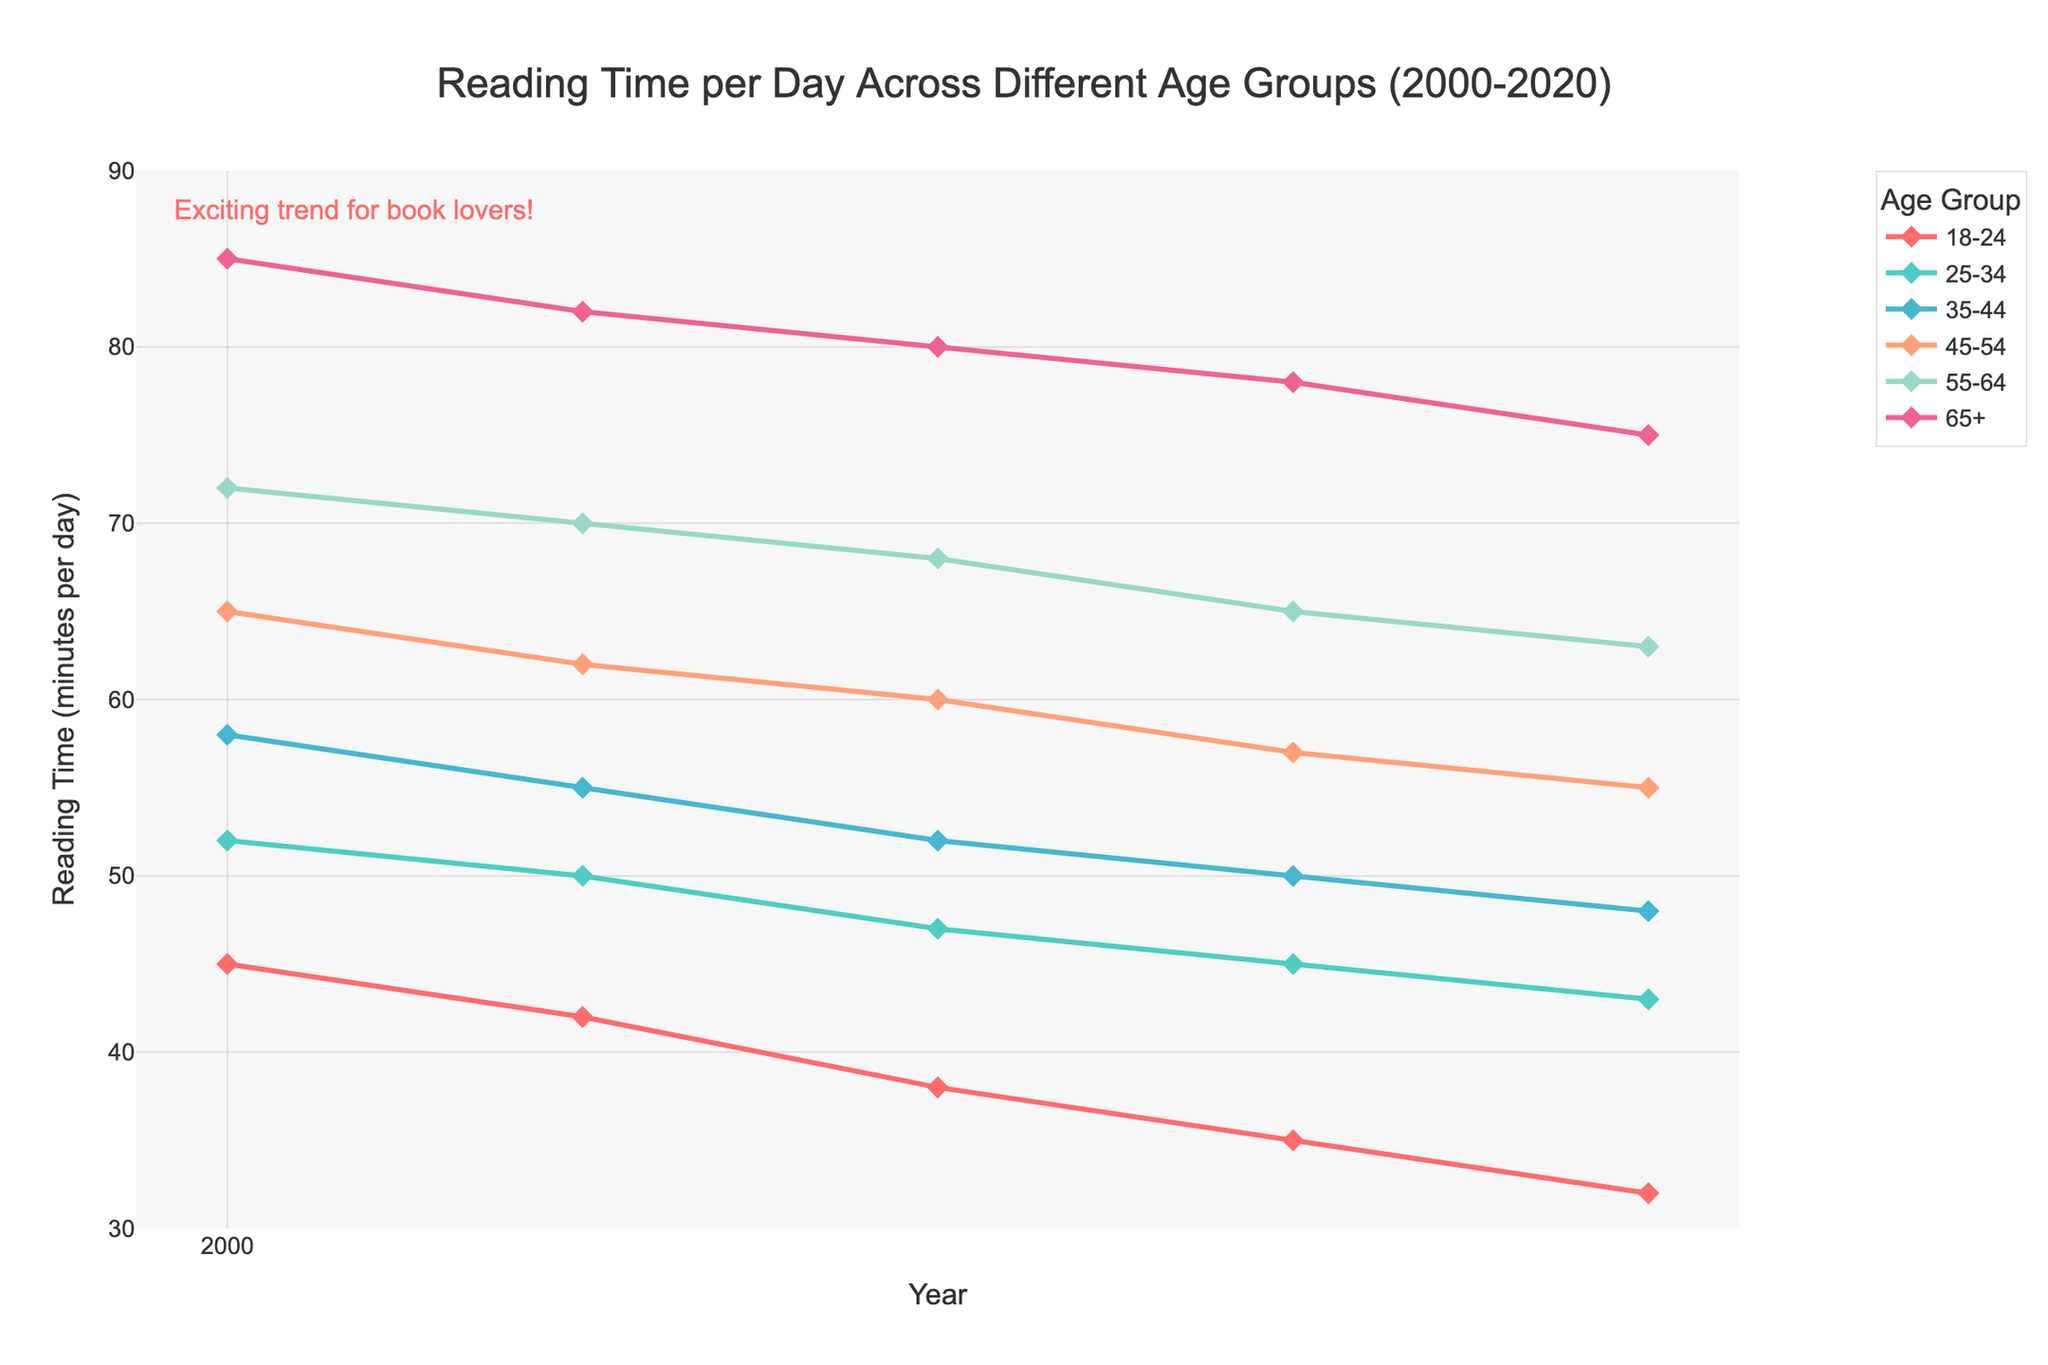Which age group had the highest reading time in the year 2000? Looking at the figure, each line represents an age group. The line with the highest point in the year 2000 indicates the age group with the highest reading time.
Answer: 65+ Which age group experienced the smallest decrease in reading time from 2000 to 2020? To find the smallest decrease, we need to subtract the 2020 value from the 2000 value for each age group. The smallest result indicates the smallest decrease.
Answer: 18-24 How much more time did the 65+ age group spend reading per day in 2005 compared to the 45-54 age group in the same year? Locate the points for the 65+ and 45-54 age groups in 2005 on the figure and find their values. Subtract the reading time of the 45-54 age group from that of the 65+ age group.
Answer: 20 minutes By how many minutes did the average reading time decrease across all age groups from 2000 to 2020? Calculate the average reading time for all age groups in 2000 and 2020 separately, then subtract the 2020 average from the 2000 average. Average in 2000: (45+52+58+65+72+85)/6 ≈ 62.83. Average in 2020: (32+43+48+55+63+75)/6 ≈ 52.67. The decrease is approximately 62.83 - 52.67 ≈ 10.17 minutes.
Answer: 10.17 minutes Which two age groups had the closest reading time in 2020? Look at the points representing the year 2020 on the figure. Identify the two age groups whose reading times are closest to each other.
Answer: 35-44 and 45-54 What is the range of reading times for the 55-64 age group over the 20-year period? Find the maximum and minimum reading times for the 55-64 age group between 2000 and 2020. The range is the difference between the maximum and the minimum.
Answer: 12 minutes In which year did the 25-34 age group’s reading time drop below 50 minutes per day? Identify when the 25-34 age group’s line crosses below the 50-minute mark on the figure’s y-axis.
Answer: 2010 Compare the trends of the 45-54 and 65+ age groups. Which group shows a steeper decline in reading time over the 20 years? Observe the slopes of the lines representing the 45-54 and 65+ age groups. A steeper line indicates a steeper decline. Calculate the differences in times over 20 years for both groups (65-55 = 10 for 45-54 and 85-75 = 10 for 65+). Both have similar declines, so neither is definitively steeper.
Answer: Neither 